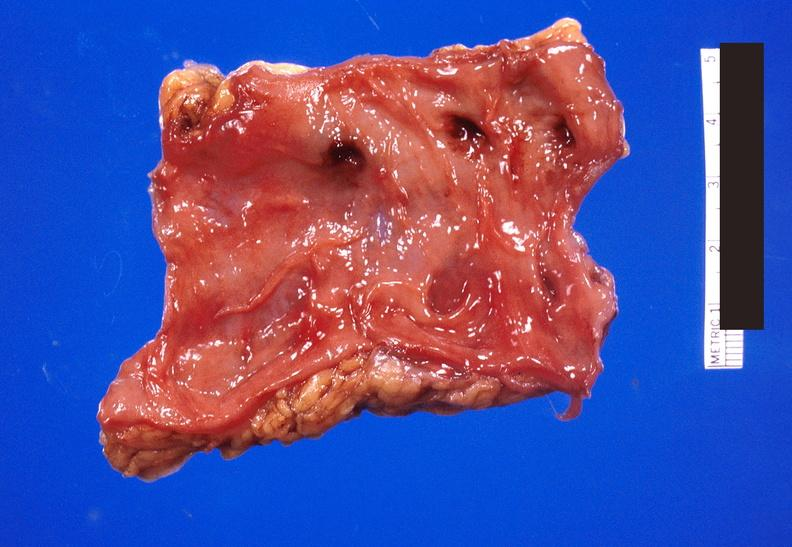what does this image show?
Answer the question using a single word or phrase. Colon polyposis 